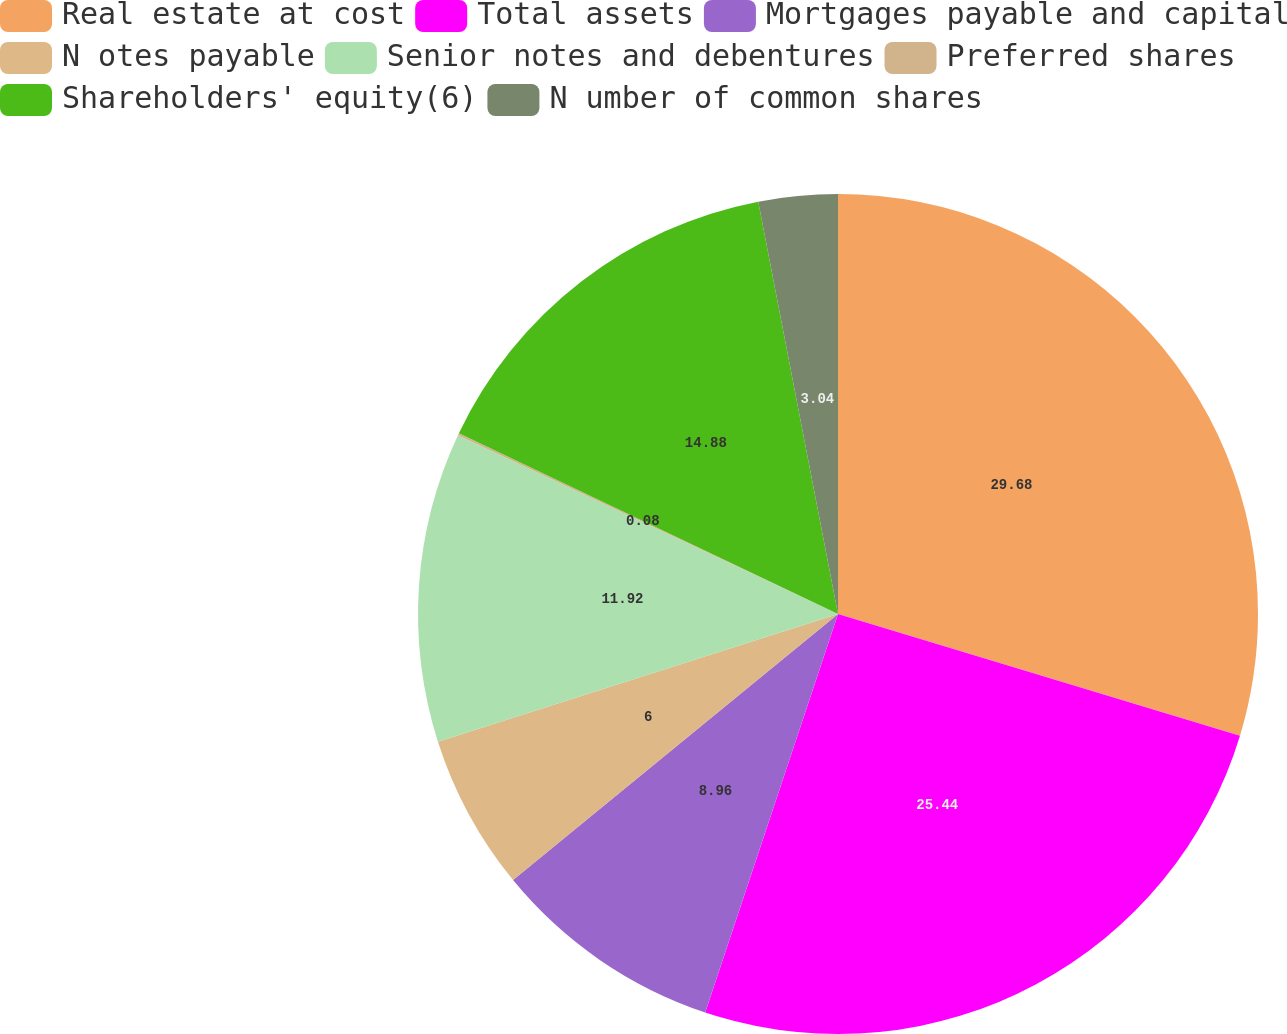<chart> <loc_0><loc_0><loc_500><loc_500><pie_chart><fcel>Real estate at cost<fcel>Total assets<fcel>Mortgages payable and capital<fcel>N otes payable<fcel>Senior notes and debentures<fcel>Preferred shares<fcel>Shareholders' equity(6)<fcel>N umber of common shares<nl><fcel>29.68%<fcel>25.44%<fcel>8.96%<fcel>6.0%<fcel>11.92%<fcel>0.08%<fcel>14.88%<fcel>3.04%<nl></chart> 